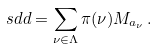<formula> <loc_0><loc_0><loc_500><loc_500>\ s d d = \sum _ { \nu \in \Lambda } \pi ( \nu ) M _ { a _ { \nu } } \, .</formula> 